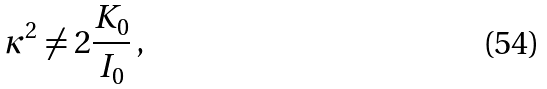Convert formula to latex. <formula><loc_0><loc_0><loc_500><loc_500>\kappa ^ { 2 } \neq 2 \frac { K _ { 0 } } { I _ { 0 } } \, ,</formula> 